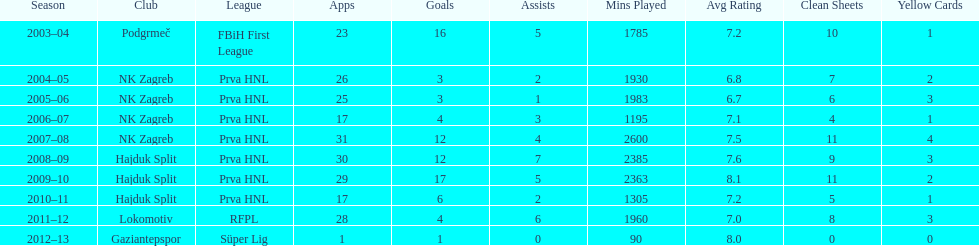Did ibricic score more or less goals in his 3 seasons with hajduk split when compared to his 4 seasons with nk zagreb? More. 